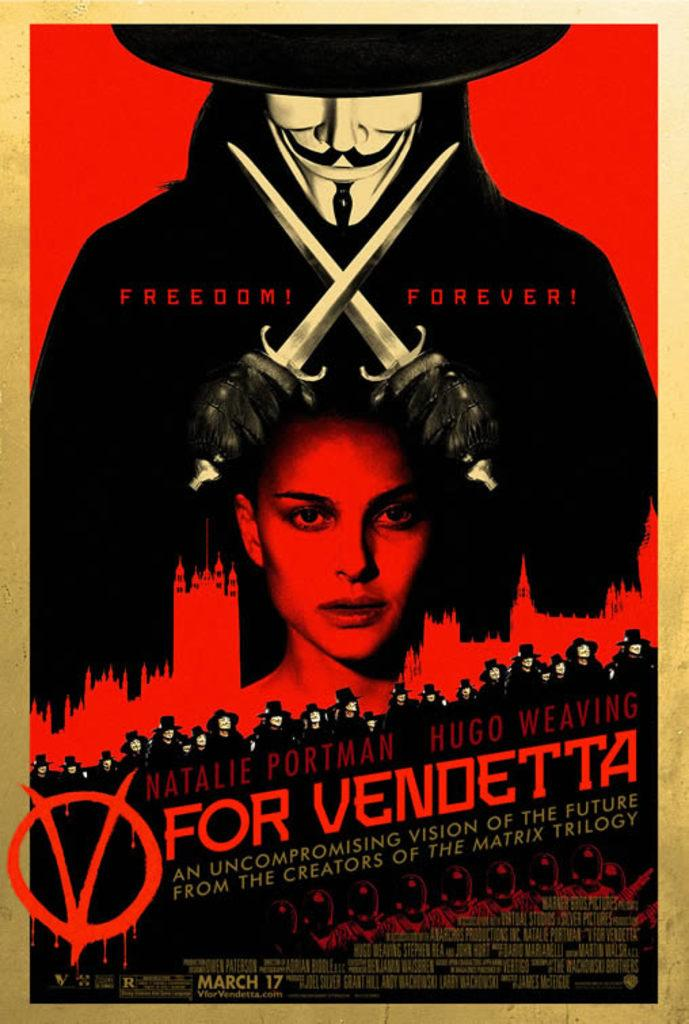Provide a one-sentence caption for the provided image. A movie poster claming "Freedom! Forever!" for the movie V for Vendetta. 